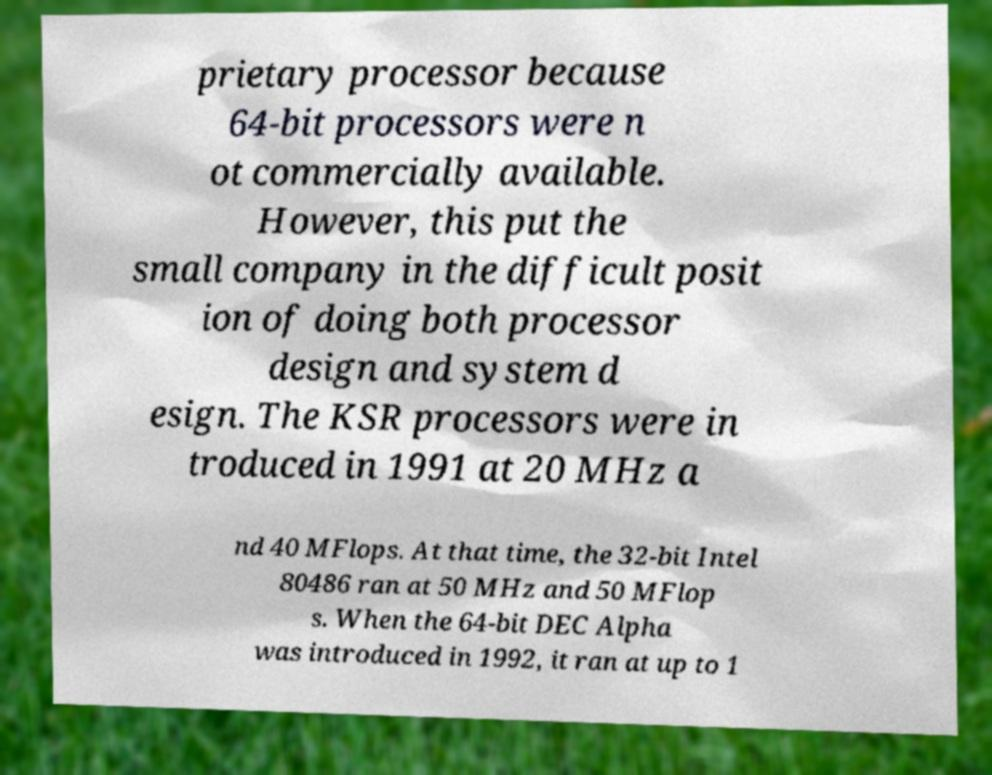Can you accurately transcribe the text from the provided image for me? prietary processor because 64-bit processors were n ot commercially available. However, this put the small company in the difficult posit ion of doing both processor design and system d esign. The KSR processors were in troduced in 1991 at 20 MHz a nd 40 MFlops. At that time, the 32-bit Intel 80486 ran at 50 MHz and 50 MFlop s. When the 64-bit DEC Alpha was introduced in 1992, it ran at up to 1 